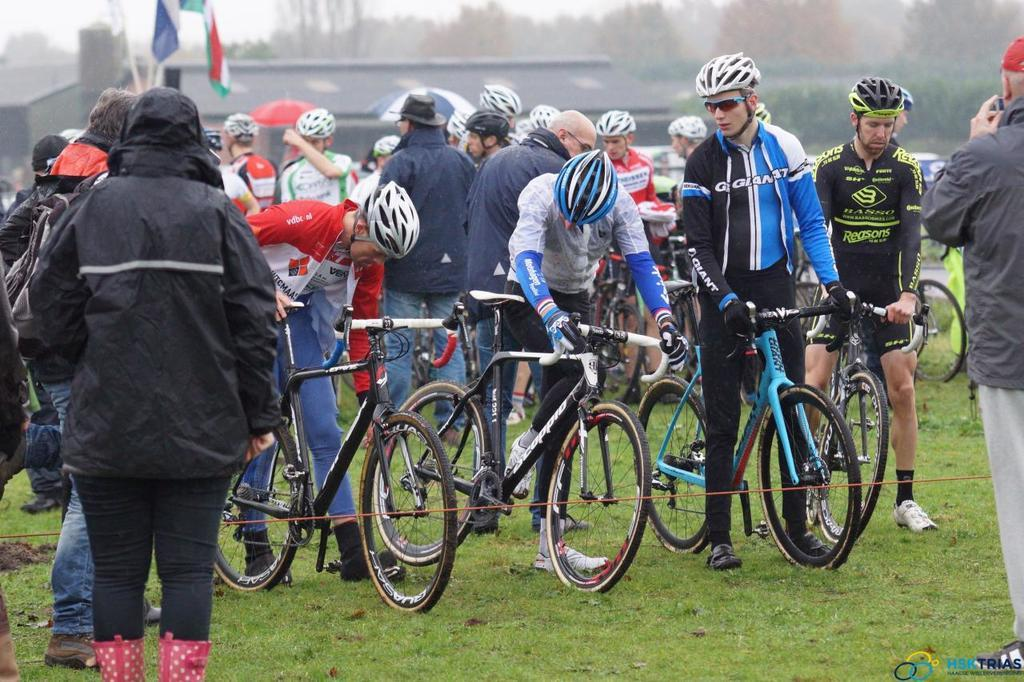How many people are in the image? There is a group of people in the image, but the exact number is not specified. What are some people doing in the image? Some people are holding a bicycle handle in the image. What safety precaution are the people taking while holding the bicycle handle? The people holding the bicycle handle are wearing helmets. What can be seen in the background of the image? There is a flag and trees in the background of the image. What type of snow can be seen on the foot of the person in the image? There is no snow or foot visible in the image. How many pages are in the book held by the person in the image? There is no book or page present in the image. 